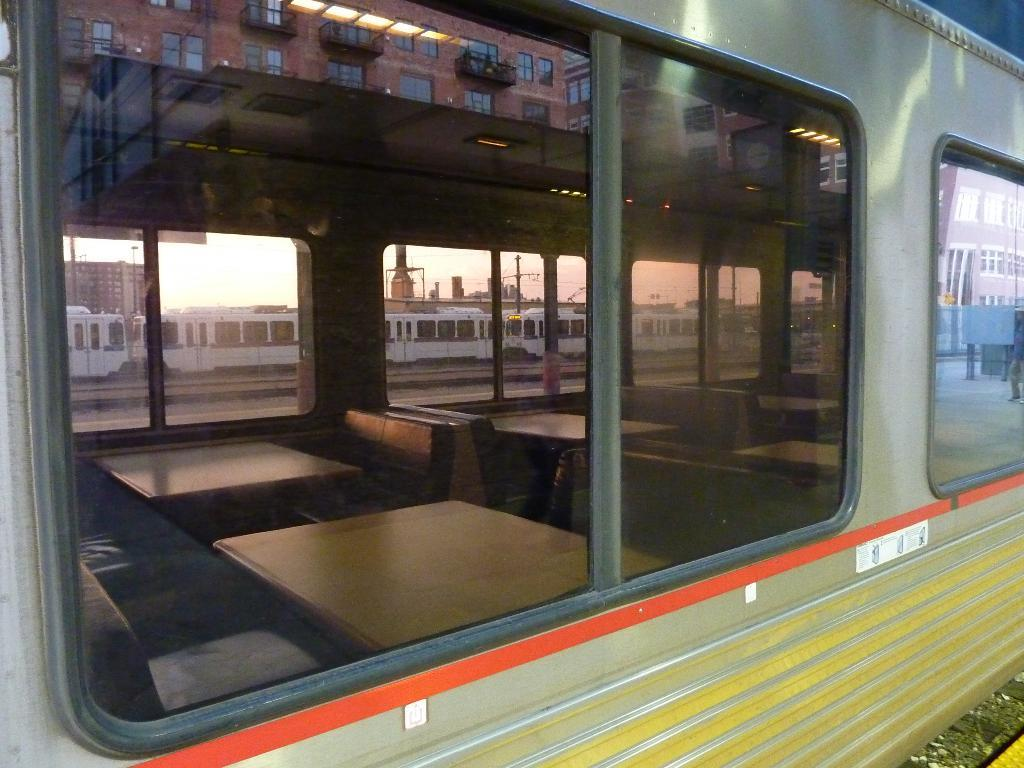What color is the train in the image? The train in the image is green. What is the color of the windows on the train? The windows on the train are black-colored. What object in the image allows for reflection? There is a mirror in the image. What color is the wall visible in the mirror? The wall visible in the mirror is brown. What type of noise can be heard coming from the tin comb in the image? There is no tin comb present in the image, so it is not possible to determine what noise might be heard. 